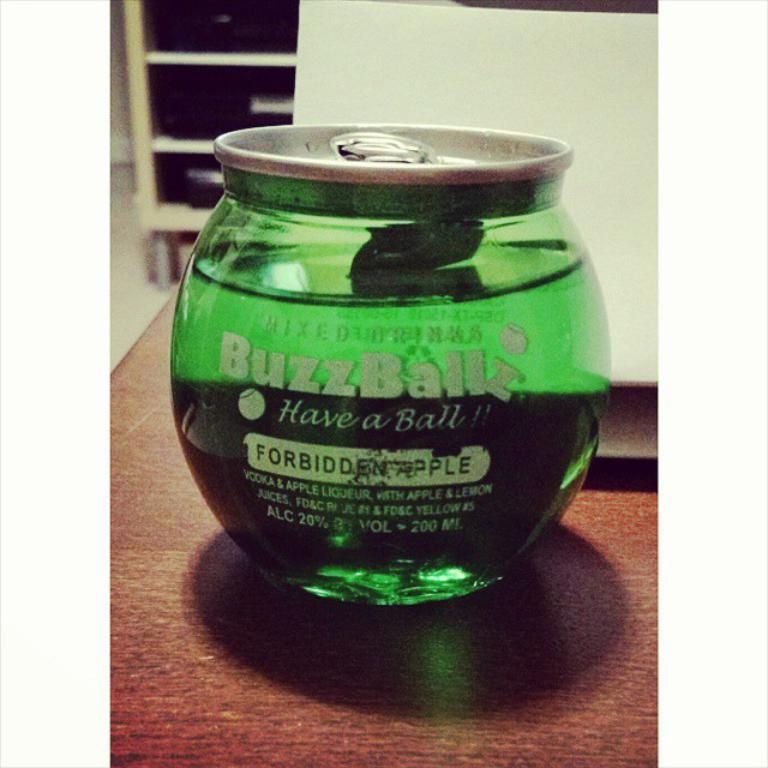Where was the image taken? The image was taken indoors. What is located at the bottom of the image? There is a table at the bottom of the image. What electronic device is on the table? A laptop is present on the table. What other object is on the table? There is a jar on the table. What can be seen in the background of the image? There is a cupboard in the background of the image. Can you see anyone using a whip in the image? No, there is no whip or anyone using a whip in the image. Is anyone wearing a veil in the image? No, there is no veil or anyone wearing a veil in the image. 